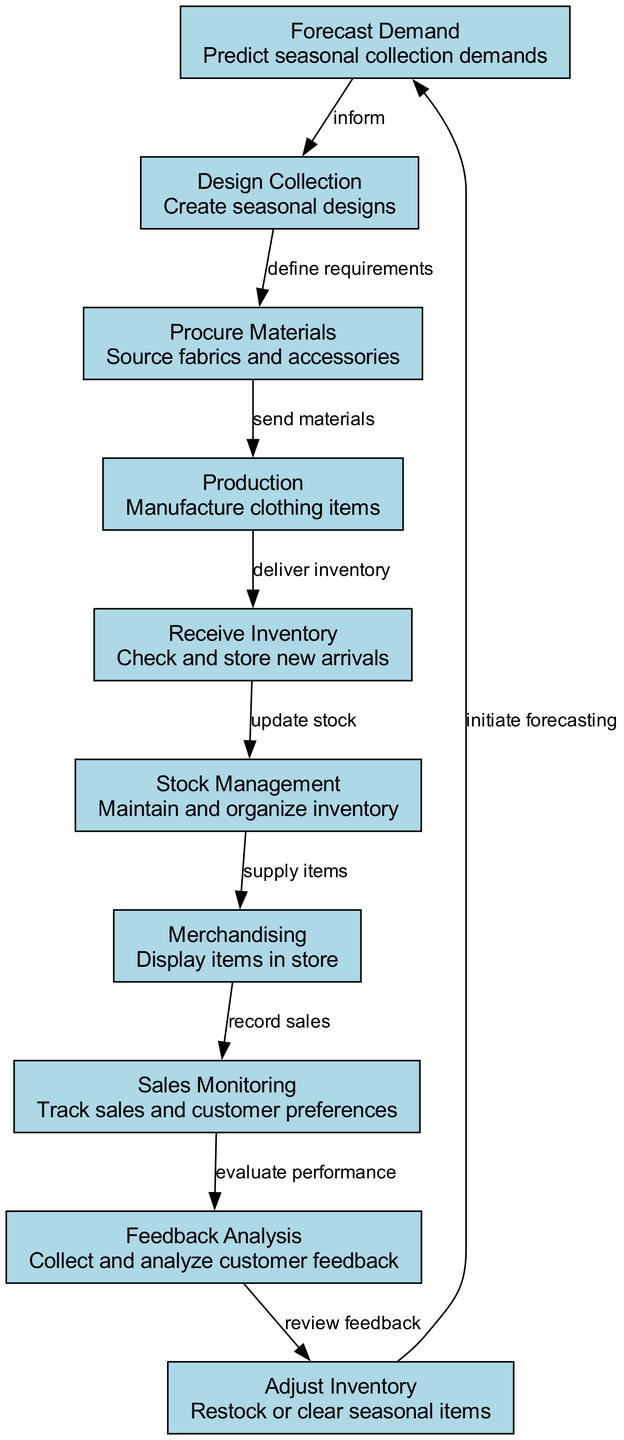What is the first step in the inventory management flowchart? The first step in the flowchart is labeled "Forecast Demand," which is indicated as the initial node in the diagram.
Answer: Forecast Demand How many total nodes are in the diagram? The diagram contains ten nodes, as can be counted from the list provided in the data.
Answer: Ten What does the "Design Collection" node receive as input? The "Design Collection" node receives input from the "Forecast Demand" node, which informs the design requirements based on predicted demands.
Answer: Forecast Demand What action follows after "Receive Inventory"? The action that follows "Receive Inventory" is "Stock Management," as indicated by the directed edge from the receiving node to the stock management node.
Answer: Stock Management Which node leads to the final step of adjusting inventory? The node that leads to the final step of adjusting inventory is "Feedback Analysis," which feeds into the "Adjust Inventory" node based on collected feedback.
Answer: Feedback Analysis What is the relationship between "Production" and "Receive Inventory"? The relationship is defined as "deliver inventory," which means that after production, the manufactured items are delivered to be received and checked.
Answer: deliver inventory Which nodes are directly connected to "Sales Monitoring"? The nodes directly connected to "Sales Monitoring" are "Merchandising," which supplies items to be sold in the store, and "Feedback Analysis," which evaluates the performance of sales.
Answer: Merchandising, Feedback Analysis How does the flowchart indicate the process of season preparation? The flowchart indicates the process for season preparation starts with "Forecast Demand," which initiates a series of actions including designing, procuring materials, and production steps until the inventory is ready for sale.
Answer: Forecast Demand What type of feedback does the "Feedback Analysis" node require? The "Feedback Analysis" node requires customer feedback, as its purpose is to collect and analyze this data to inform future inventory adjustments.
Answer: Customer feedback 